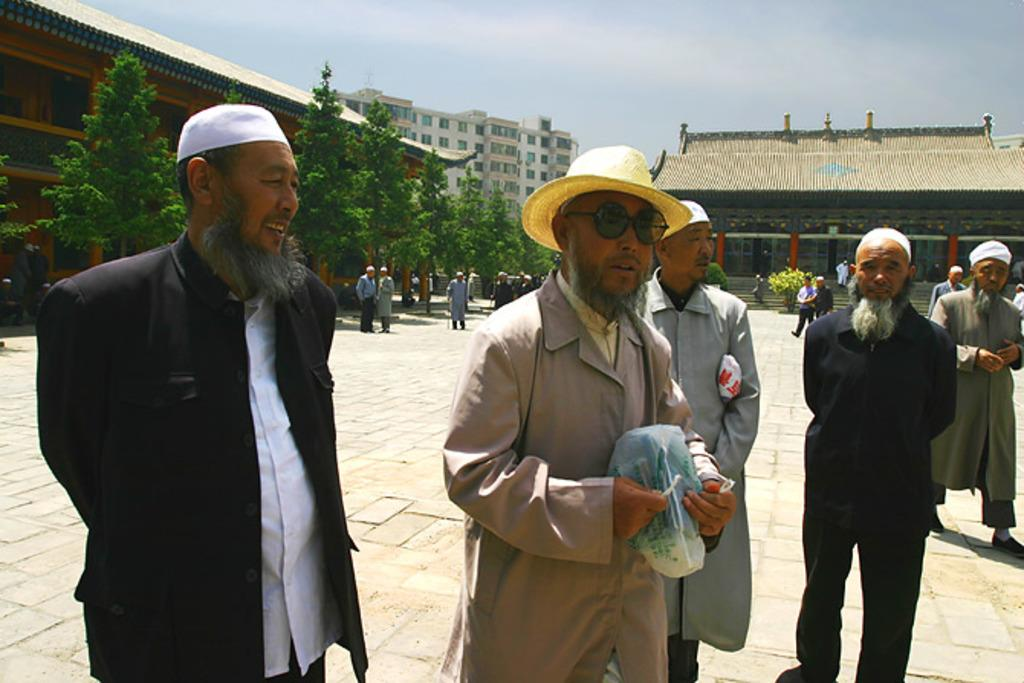What are the people in the image wearing on their heads? There are people wearing hats in the image. What can be seen in the distance behind the people? There are buildings, trees, and plants in the background of the image. Are there any other people visible in the image? Yes, there are other people in the background of the image. What decision did the doll make before the event in the image? There is no doll present in the image, so it is not possible to answer a question about a decision made by a doll. 